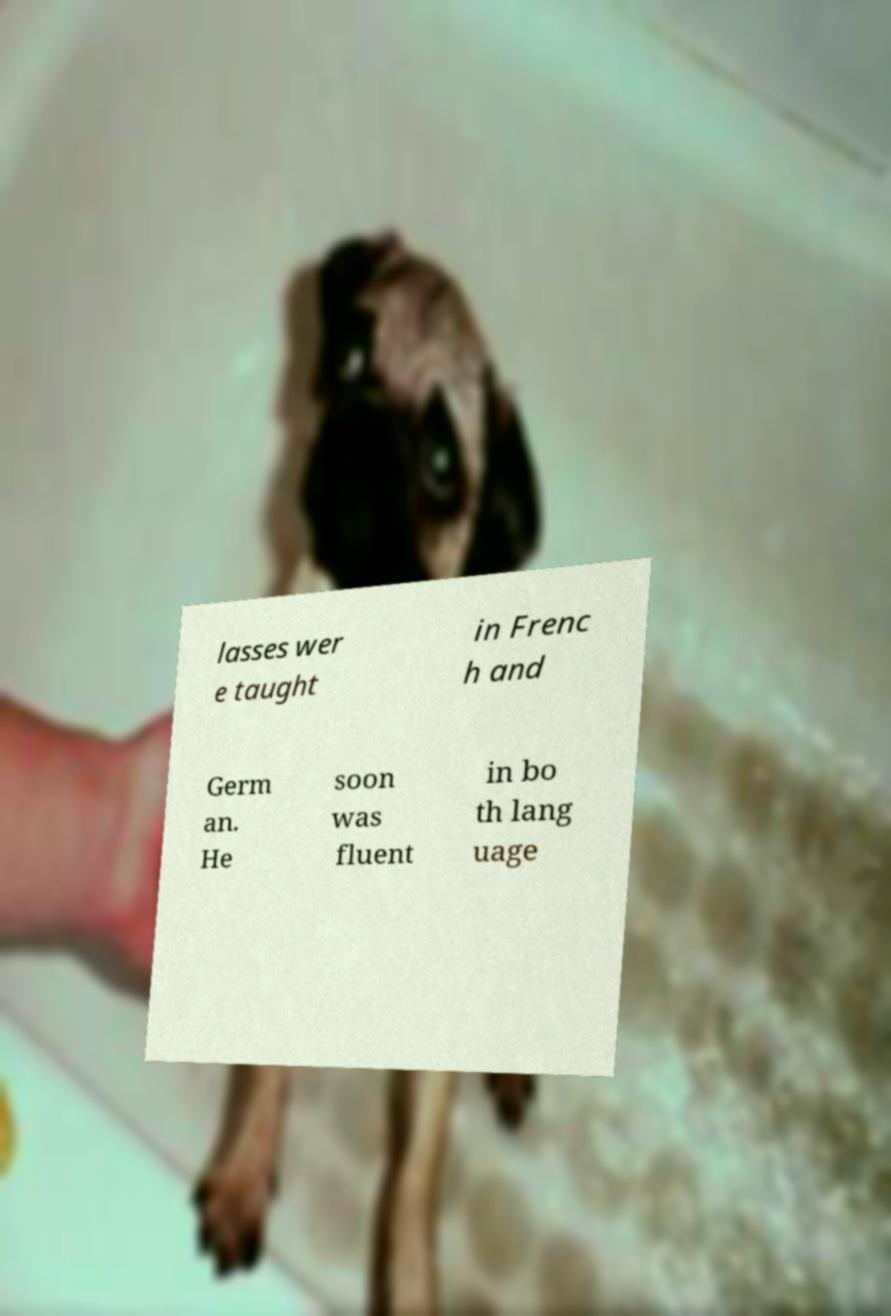For documentation purposes, I need the text within this image transcribed. Could you provide that? lasses wer e taught in Frenc h and Germ an. He soon was fluent in bo th lang uage 